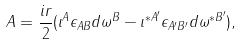<formula> <loc_0><loc_0><loc_500><loc_500>A = \frac { i r } { 2 } ( \iota ^ { A } \epsilon _ { A B } d \omega ^ { B } - \iota ^ { * A ^ { \prime } } \epsilon _ { A ^ { \prime } B ^ { \prime } } d \omega ^ { * B ^ { \prime } } ) ,</formula> 